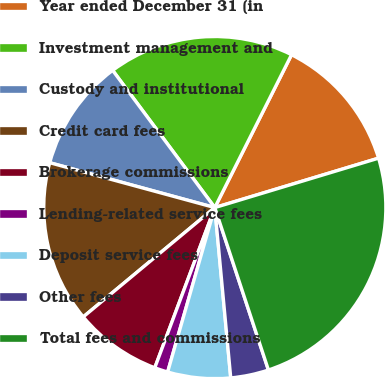<chart> <loc_0><loc_0><loc_500><loc_500><pie_chart><fcel>Year ended December 31 (in<fcel>Investment management and<fcel>Custody and institutional<fcel>Credit card fees<fcel>Brokerage commissions<fcel>Lending-related service fees<fcel>Deposit service fees<fcel>Other fees<fcel>Total fees and commissions<nl><fcel>12.93%<fcel>17.59%<fcel>10.59%<fcel>15.26%<fcel>8.26%<fcel>1.26%<fcel>5.93%<fcel>3.59%<fcel>24.59%<nl></chart> 